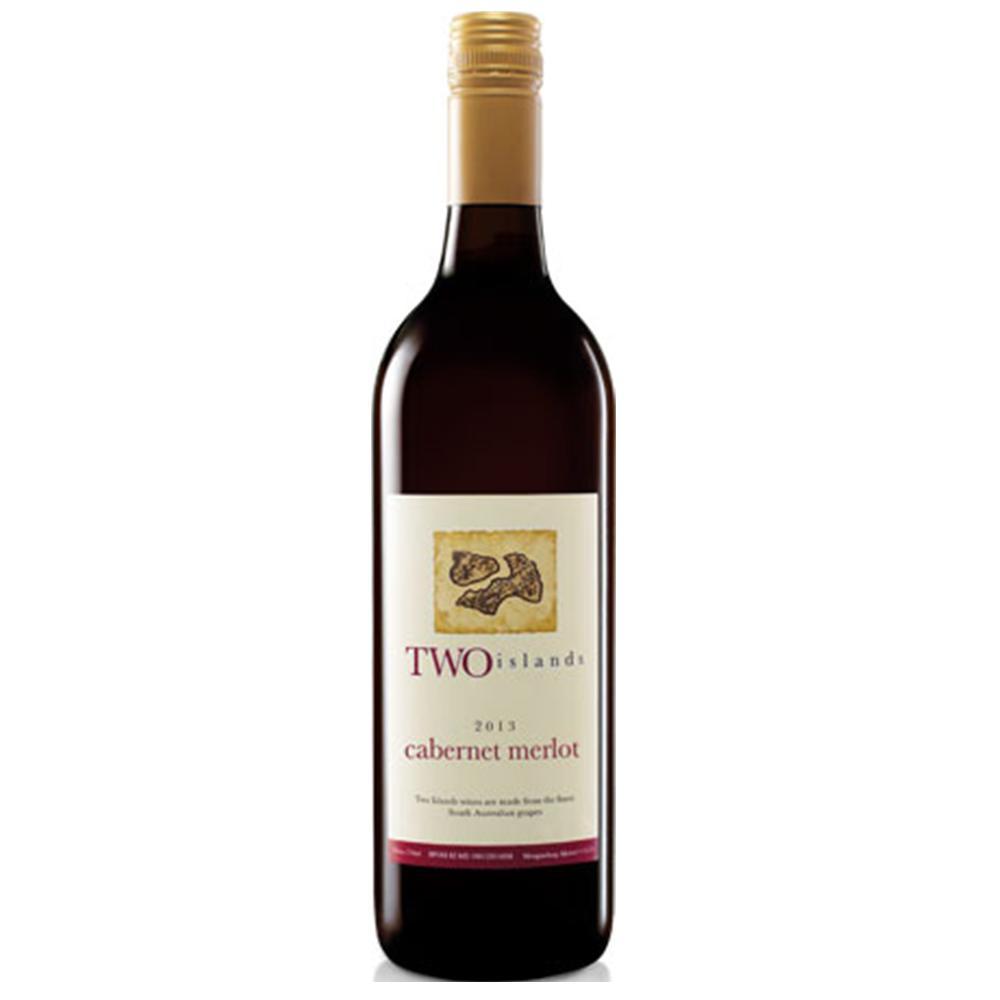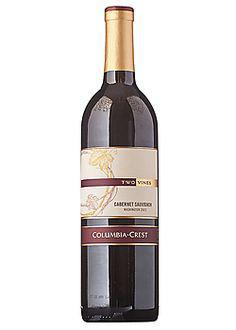The first image is the image on the left, the second image is the image on the right. Examine the images to the left and right. Is the description "There is at least 1 wine bottle with a red cap." accurate? Answer yes or no. No. The first image is the image on the left, the second image is the image on the right. For the images shown, is this caption "at least one bottle has a tan colored top" true? Answer yes or no. Yes. 